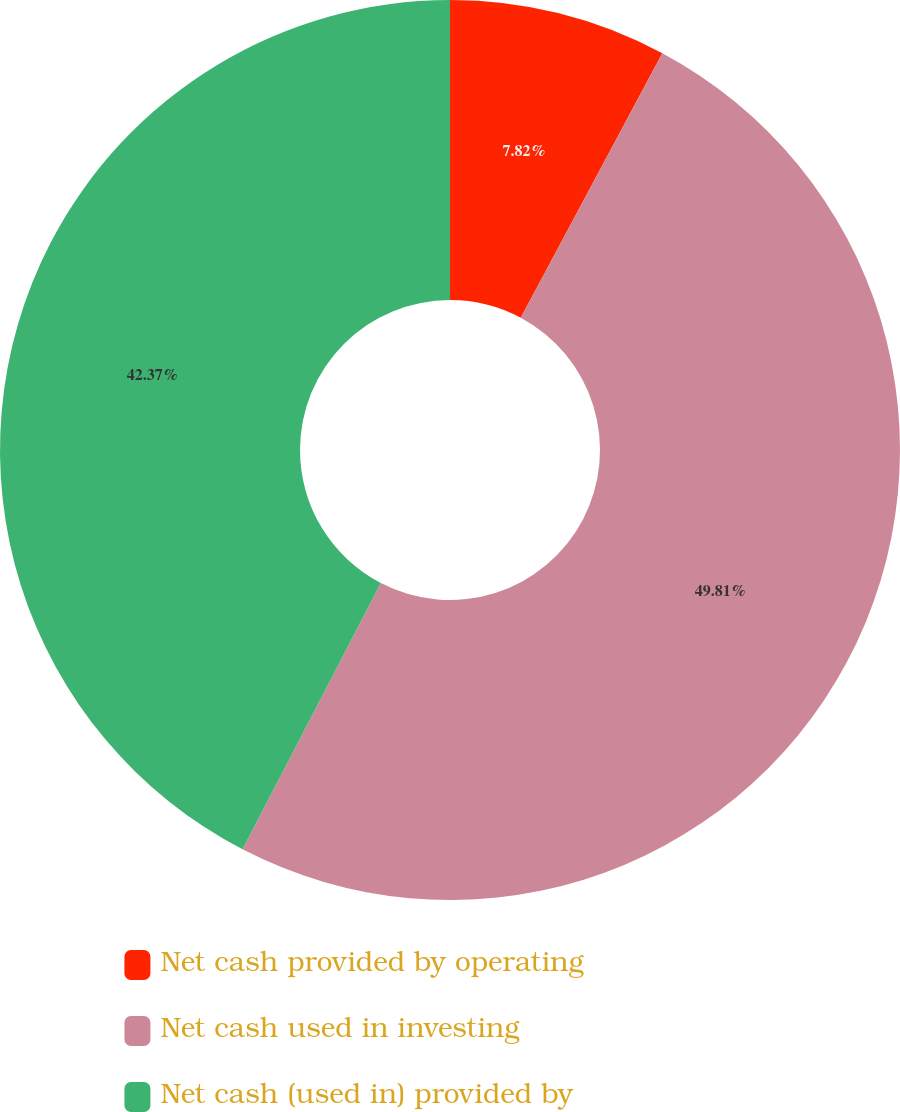Convert chart. <chart><loc_0><loc_0><loc_500><loc_500><pie_chart><fcel>Net cash provided by operating<fcel>Net cash used in investing<fcel>Net cash (used in) provided by<nl><fcel>7.82%<fcel>49.8%<fcel>42.37%<nl></chart> 